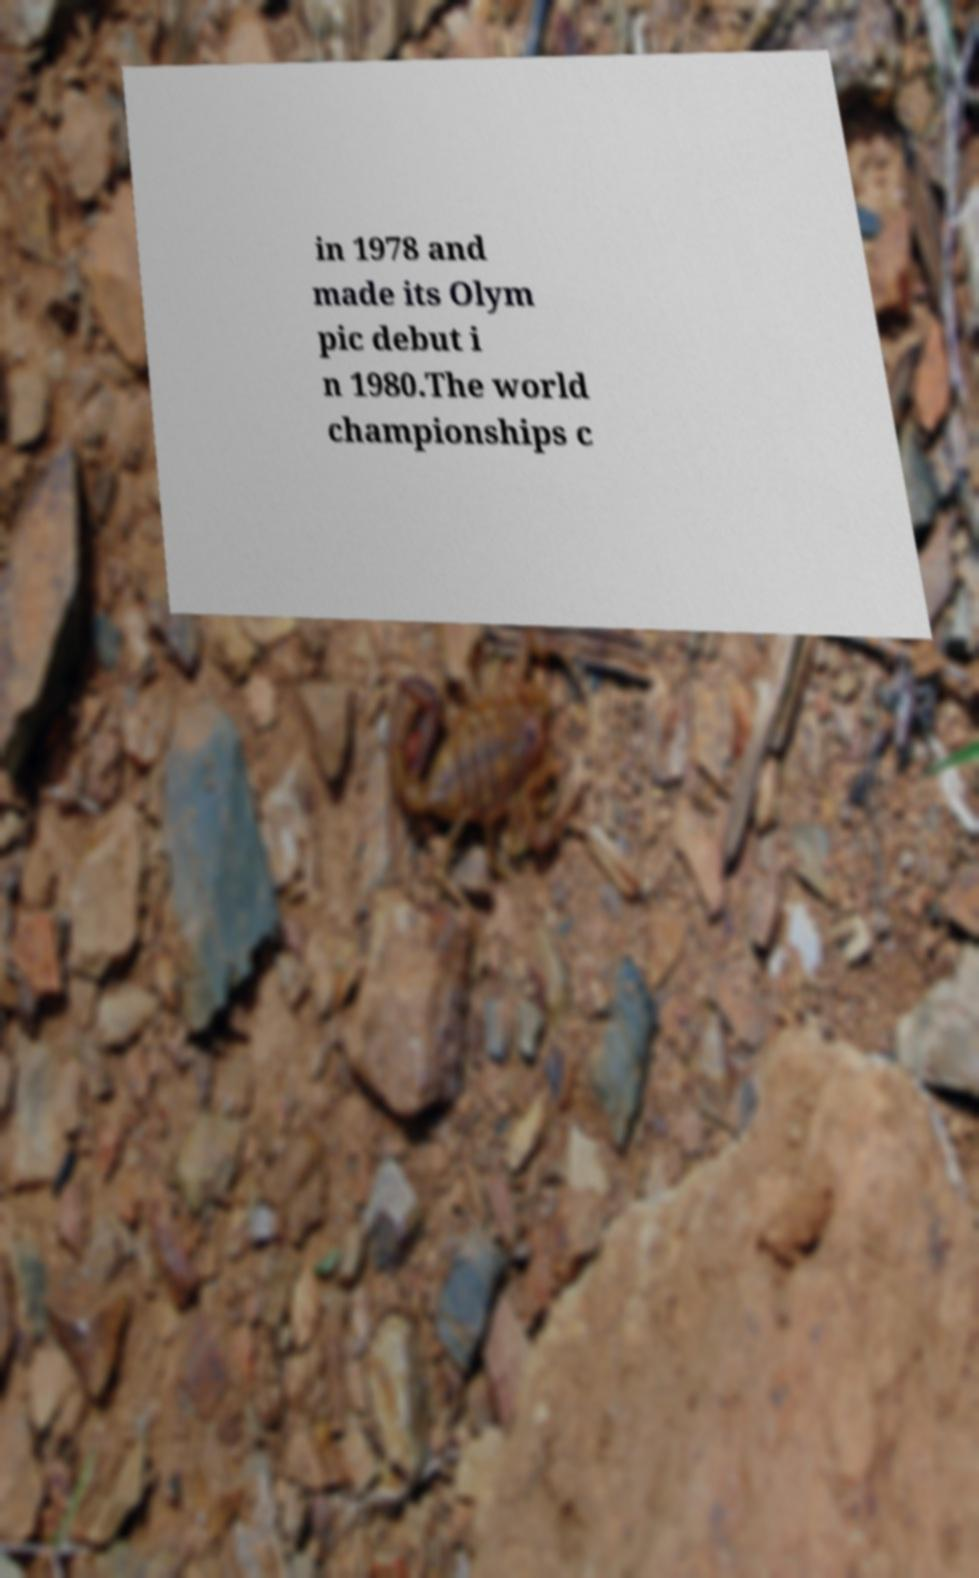There's text embedded in this image that I need extracted. Can you transcribe it verbatim? in 1978 and made its Olym pic debut i n 1980.The world championships c 